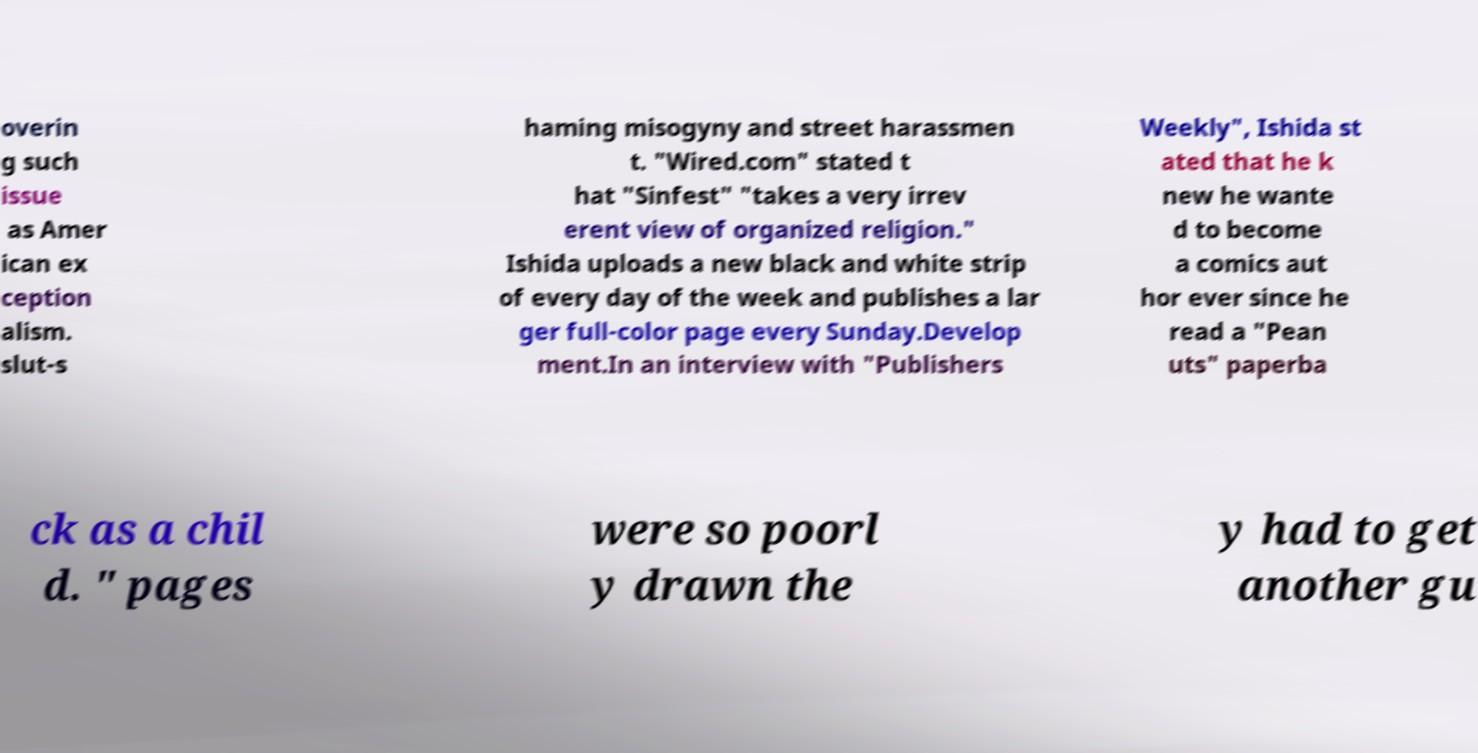Please read and relay the text visible in this image. What does it say? overin g such issue as Amer ican ex ception alism. slut-s haming misogyny and street harassmen t. "Wired.com" stated t hat "Sinfest" "takes a very irrev erent view of organized religion." Ishida uploads a new black and white strip of every day of the week and publishes a lar ger full-color page every Sunday.Develop ment.In an interview with "Publishers Weekly", Ishida st ated that he k new he wante d to become a comics aut hor ever since he read a "Pean uts" paperba ck as a chil d. " pages were so poorl y drawn the y had to get another gu 